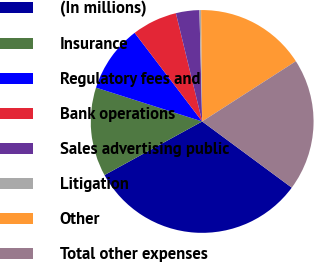Convert chart to OTSL. <chart><loc_0><loc_0><loc_500><loc_500><pie_chart><fcel>(In millions)<fcel>Insurance<fcel>Regulatory fees and<fcel>Bank operations<fcel>Sales advertising public<fcel>Litigation<fcel>Other<fcel>Total other expenses<nl><fcel>31.88%<fcel>12.9%<fcel>9.73%<fcel>6.57%<fcel>3.4%<fcel>0.24%<fcel>16.06%<fcel>19.22%<nl></chart> 